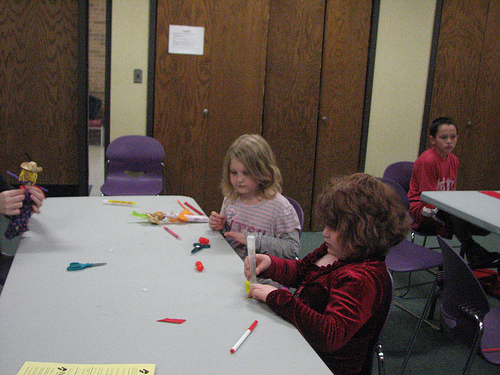<image>
Is the girl in front of the girl? Yes. The girl is positioned in front of the girl, appearing closer to the camera viewpoint. Where is the scarecrow in relation to the scissors? Is it above the scissors? Yes. The scarecrow is positioned above the scissors in the vertical space, higher up in the scene. 